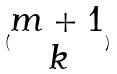<formula> <loc_0><loc_0><loc_500><loc_500>( \begin{matrix} m + 1 \\ k \end{matrix} )</formula> 